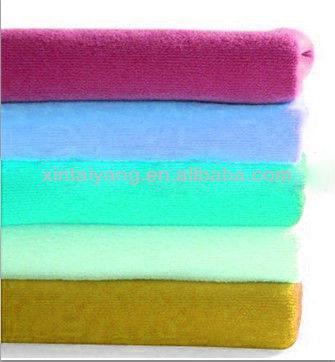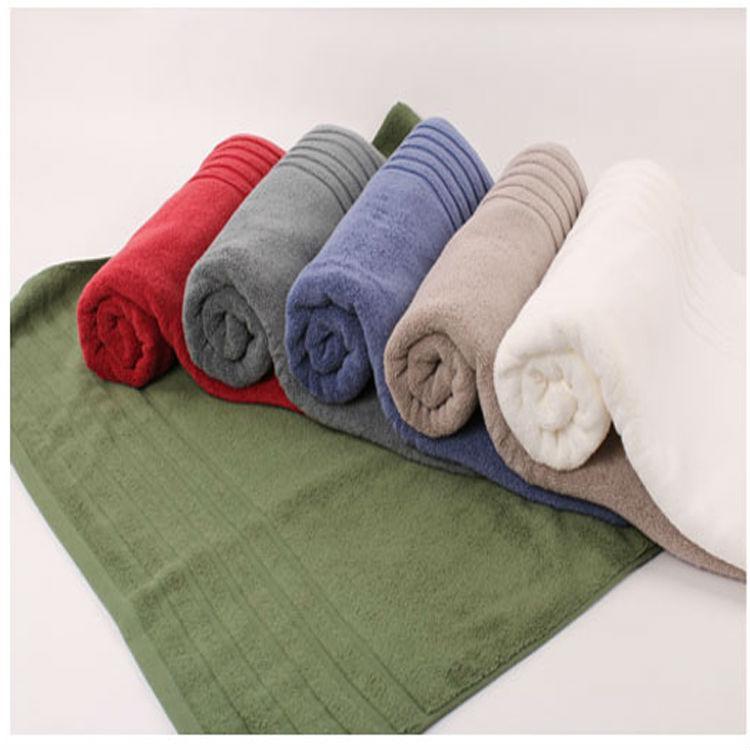The first image is the image on the left, the second image is the image on the right. Analyze the images presented: Is the assertion "There are exactly five towels in the left image." valid? Answer yes or no. Yes. The first image is the image on the left, the second image is the image on the right. Assess this claim about the two images: "There is a single tower of five towels.". Correct or not? Answer yes or no. Yes. 